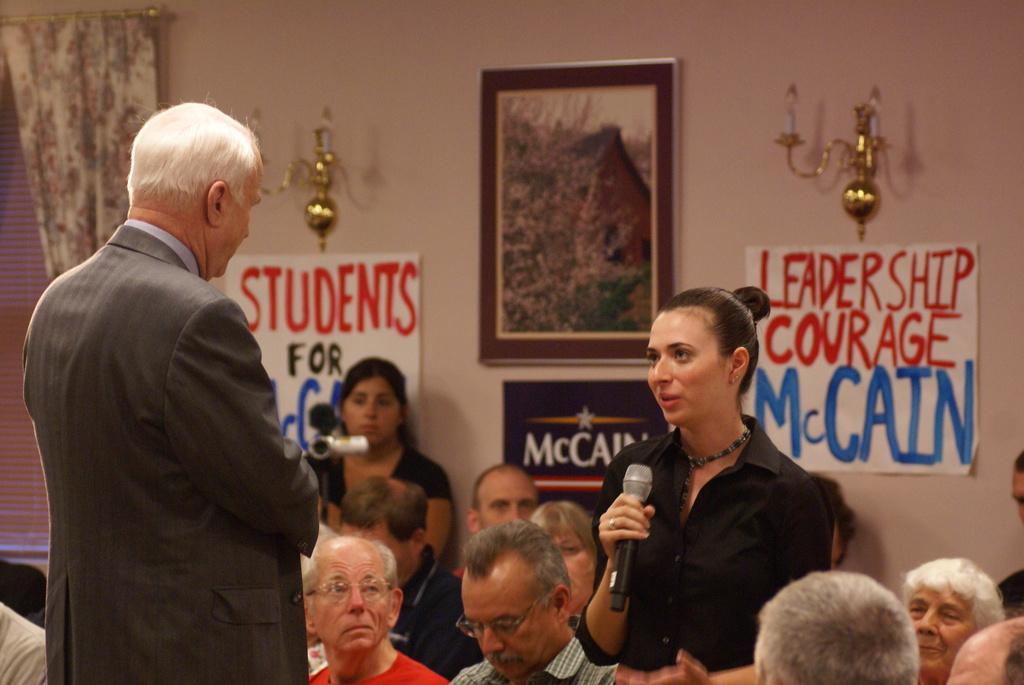Describe this image in one or two sentences. In this image in the foreground there is one man and one woman standing, woman is holding a mike and talking and there are a group of people sitting. And in the background there is one woman, who is holding a camera and standing and there are some photo frames and posters and candles on the wall. On the left side there is a window and curtain. 